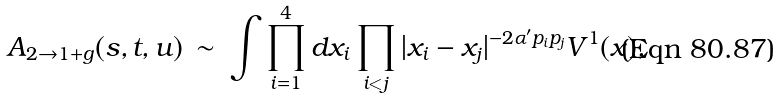<formula> <loc_0><loc_0><loc_500><loc_500>A _ { 2 \rightarrow 1 + g } ( s , t , u ) \, \sim \, \int \prod _ { i = 1 } ^ { 4 } d x _ { i } \prod _ { i < j } | x _ { i } - x _ { j } | ^ { - 2 \alpha ^ { \prime } p _ { i } p _ { j } } V ^ { 1 } ( x ) ,</formula> 